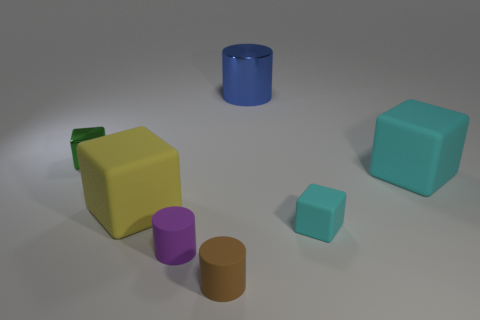The purple cylinder that is made of the same material as the large yellow cube is what size?
Offer a terse response. Small. What number of blocks are small cyan matte things or brown objects?
Give a very brief answer. 1. Are there more tiny green metal objects than big things?
Make the answer very short. No. How many green metallic cylinders are the same size as the yellow block?
Make the answer very short. 0. There is a large rubber thing that is the same color as the tiny matte cube; what shape is it?
Give a very brief answer. Cube. How many things are tiny brown cylinders that are in front of the purple cylinder or big yellow metal objects?
Your answer should be very brief. 1. Is the number of small red objects less than the number of blocks?
Provide a succinct answer. Yes. There is a large cyan thing that is the same material as the small brown cylinder; what shape is it?
Your answer should be very brief. Cube. There is a small purple cylinder; are there any big cubes right of it?
Give a very brief answer. Yes. Are there fewer small green metal blocks that are right of the small green metallic block than brown rubber cylinders?
Keep it short and to the point. Yes. 